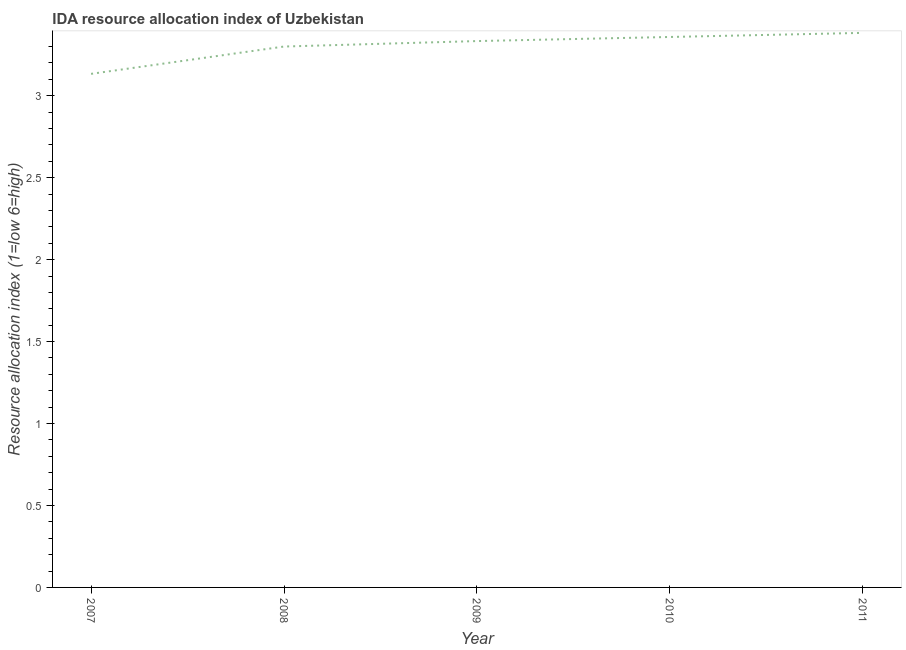What is the ida resource allocation index in 2009?
Offer a terse response. 3.33. Across all years, what is the maximum ida resource allocation index?
Make the answer very short. 3.38. Across all years, what is the minimum ida resource allocation index?
Provide a short and direct response. 3.13. What is the sum of the ida resource allocation index?
Ensure brevity in your answer.  16.51. What is the difference between the ida resource allocation index in 2009 and 2011?
Provide a short and direct response. -0.05. What is the average ida resource allocation index per year?
Give a very brief answer. 3.3. What is the median ida resource allocation index?
Your answer should be compact. 3.33. In how many years, is the ida resource allocation index greater than 1.8 ?
Give a very brief answer. 5. What is the ratio of the ida resource allocation index in 2007 to that in 2008?
Keep it short and to the point. 0.95. What is the difference between the highest and the second highest ida resource allocation index?
Make the answer very short. 0.03. Is the sum of the ida resource allocation index in 2007 and 2011 greater than the maximum ida resource allocation index across all years?
Provide a succinct answer. Yes. What is the difference between the highest and the lowest ida resource allocation index?
Offer a very short reply. 0.25. In how many years, is the ida resource allocation index greater than the average ida resource allocation index taken over all years?
Keep it short and to the point. 3. What is the difference between two consecutive major ticks on the Y-axis?
Keep it short and to the point. 0.5. Does the graph contain any zero values?
Provide a short and direct response. No. Does the graph contain grids?
Your response must be concise. No. What is the title of the graph?
Your answer should be compact. IDA resource allocation index of Uzbekistan. What is the label or title of the Y-axis?
Offer a terse response. Resource allocation index (1=low 6=high). What is the Resource allocation index (1=low 6=high) of 2007?
Provide a succinct answer. 3.13. What is the Resource allocation index (1=low 6=high) of 2009?
Your answer should be very brief. 3.33. What is the Resource allocation index (1=low 6=high) in 2010?
Provide a succinct answer. 3.36. What is the Resource allocation index (1=low 6=high) in 2011?
Your response must be concise. 3.38. What is the difference between the Resource allocation index (1=low 6=high) in 2007 and 2008?
Make the answer very short. -0.17. What is the difference between the Resource allocation index (1=low 6=high) in 2007 and 2010?
Make the answer very short. -0.23. What is the difference between the Resource allocation index (1=low 6=high) in 2008 and 2009?
Provide a succinct answer. -0.03. What is the difference between the Resource allocation index (1=low 6=high) in 2008 and 2010?
Give a very brief answer. -0.06. What is the difference between the Resource allocation index (1=low 6=high) in 2008 and 2011?
Offer a terse response. -0.08. What is the difference between the Resource allocation index (1=low 6=high) in 2009 and 2010?
Provide a succinct answer. -0.03. What is the difference between the Resource allocation index (1=low 6=high) in 2010 and 2011?
Offer a terse response. -0.03. What is the ratio of the Resource allocation index (1=low 6=high) in 2007 to that in 2008?
Keep it short and to the point. 0.95. What is the ratio of the Resource allocation index (1=low 6=high) in 2007 to that in 2009?
Give a very brief answer. 0.94. What is the ratio of the Resource allocation index (1=low 6=high) in 2007 to that in 2010?
Your answer should be very brief. 0.93. What is the ratio of the Resource allocation index (1=low 6=high) in 2007 to that in 2011?
Give a very brief answer. 0.93. What is the ratio of the Resource allocation index (1=low 6=high) in 2008 to that in 2009?
Your answer should be very brief. 0.99. What is the ratio of the Resource allocation index (1=low 6=high) in 2008 to that in 2011?
Your response must be concise. 0.97. What is the ratio of the Resource allocation index (1=low 6=high) in 2009 to that in 2010?
Your answer should be compact. 0.99. 